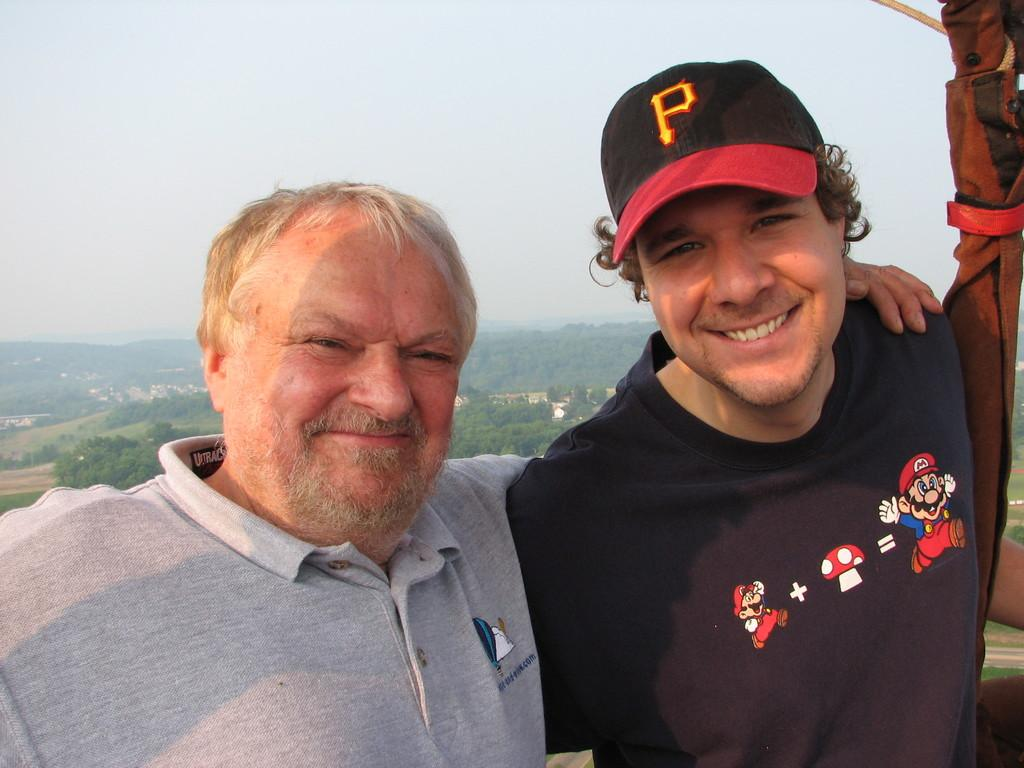How many people are in the image? There are two men in the image. What is located on the right side of the image? There is a cloth on the right side of the image. What can be seen in the background of the image? There are trees, houses, plants, and mountains in the background of the image. What is visible at the top of the image? The sky is visible at the top of the image. What color is the straw that the orange is sitting on in the image? There is no straw or orange present in the image. 